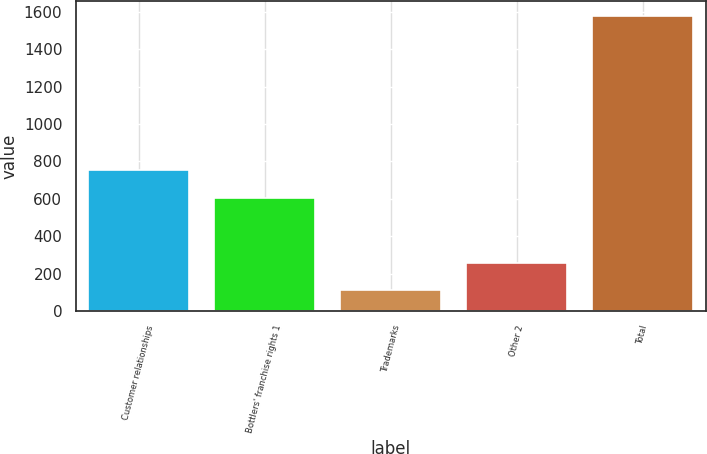<chart> <loc_0><loc_0><loc_500><loc_500><bar_chart><fcel>Customer relationships<fcel>Bottlers' franchise rights 1<fcel>Trademarks<fcel>Other 2<fcel>Total<nl><fcel>751.9<fcel>605<fcel>111<fcel>258<fcel>1580<nl></chart> 